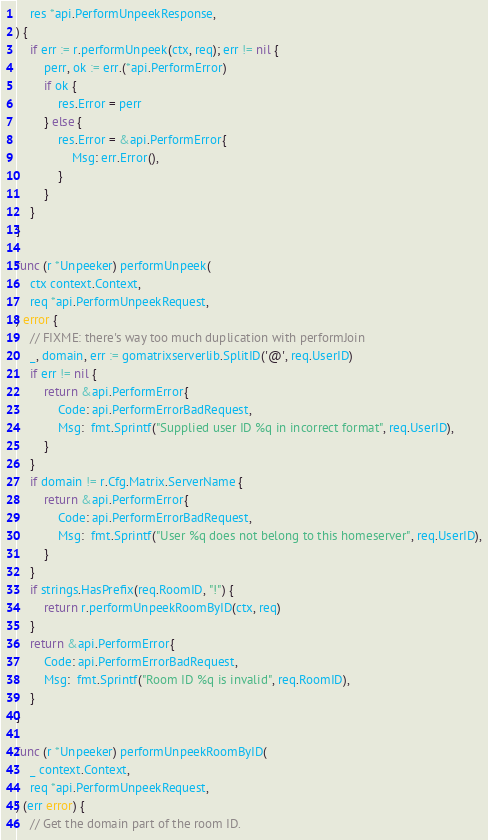<code> <loc_0><loc_0><loc_500><loc_500><_Go_>	res *api.PerformUnpeekResponse,
) {
	if err := r.performUnpeek(ctx, req); err != nil {
		perr, ok := err.(*api.PerformError)
		if ok {
			res.Error = perr
		} else {
			res.Error = &api.PerformError{
				Msg: err.Error(),
			}
		}
	}
}

func (r *Unpeeker) performUnpeek(
	ctx context.Context,
	req *api.PerformUnpeekRequest,
) error {
	// FIXME: there's way too much duplication with performJoin
	_, domain, err := gomatrixserverlib.SplitID('@', req.UserID)
	if err != nil {
		return &api.PerformError{
			Code: api.PerformErrorBadRequest,
			Msg:  fmt.Sprintf("Supplied user ID %q in incorrect format", req.UserID),
		}
	}
	if domain != r.Cfg.Matrix.ServerName {
		return &api.PerformError{
			Code: api.PerformErrorBadRequest,
			Msg:  fmt.Sprintf("User %q does not belong to this homeserver", req.UserID),
		}
	}
	if strings.HasPrefix(req.RoomID, "!") {
		return r.performUnpeekRoomByID(ctx, req)
	}
	return &api.PerformError{
		Code: api.PerformErrorBadRequest,
		Msg:  fmt.Sprintf("Room ID %q is invalid", req.RoomID),
	}
}

func (r *Unpeeker) performUnpeekRoomByID(
	_ context.Context,
	req *api.PerformUnpeekRequest,
) (err error) {
	// Get the domain part of the room ID.</code> 